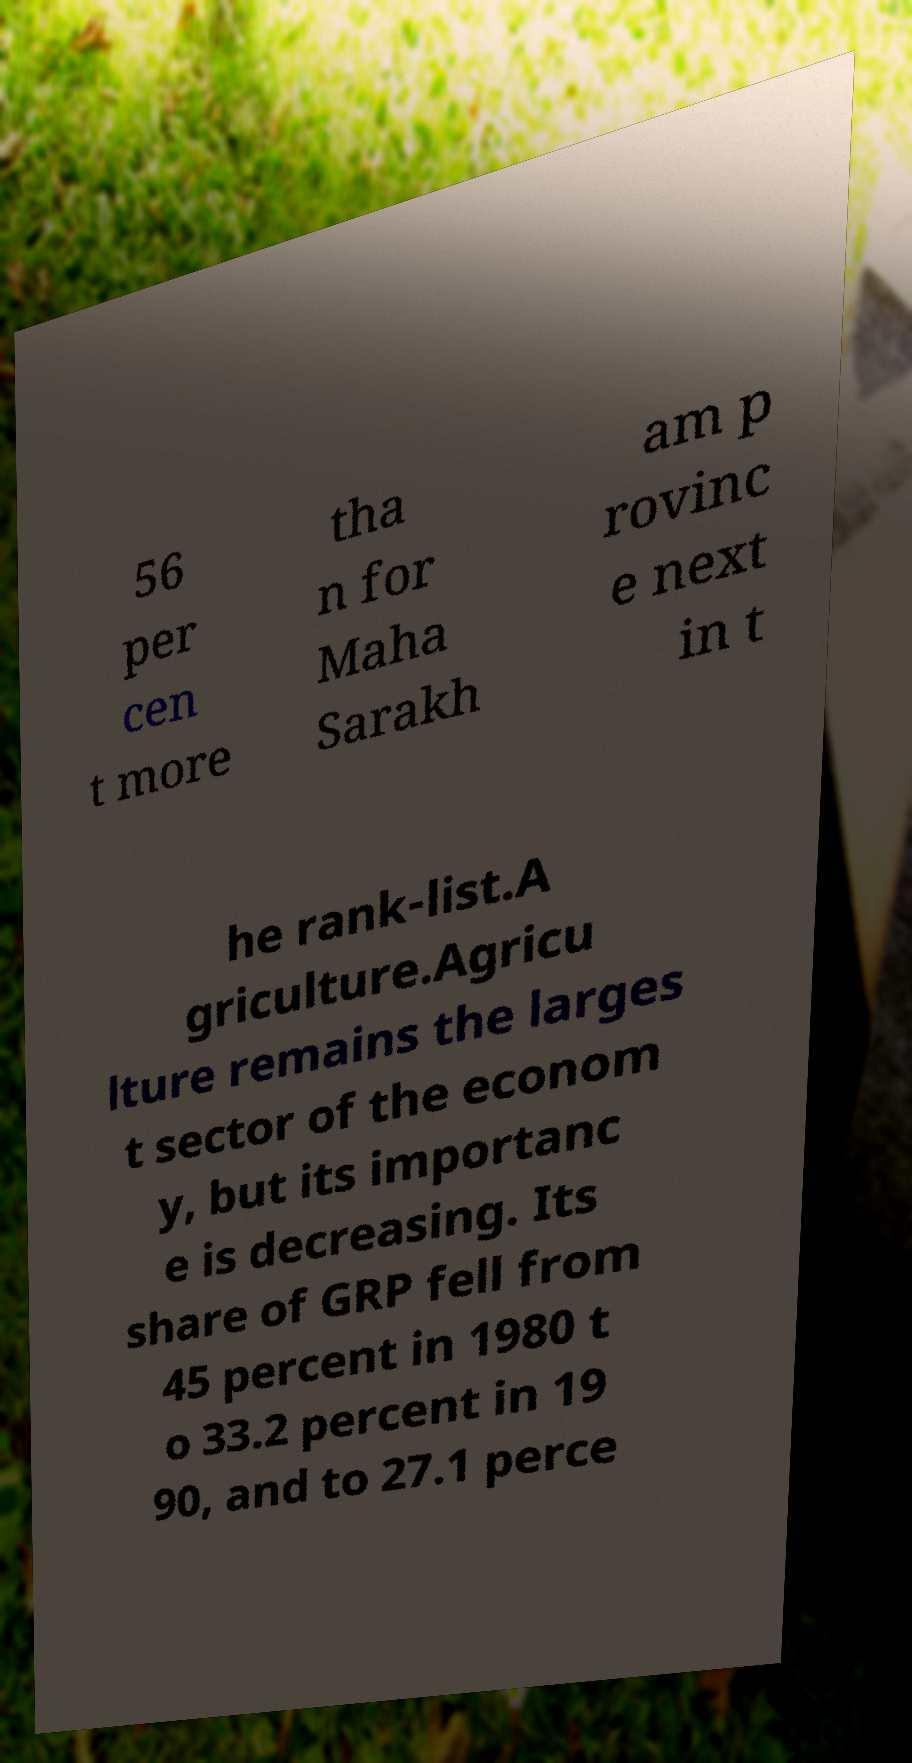There's text embedded in this image that I need extracted. Can you transcribe it verbatim? 56 per cen t more tha n for Maha Sarakh am p rovinc e next in t he rank-list.A griculture.Agricu lture remains the larges t sector of the econom y, but its importanc e is decreasing. Its share of GRP fell from 45 percent in 1980 t o 33.2 percent in 19 90, and to 27.1 perce 